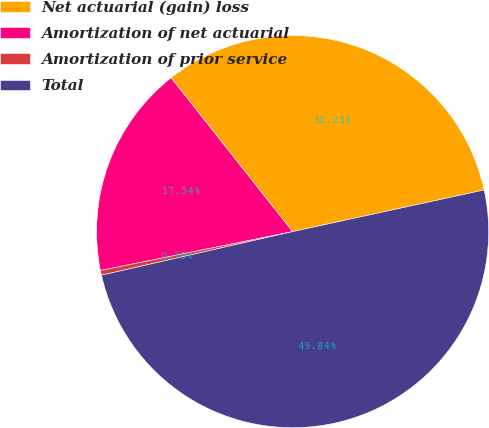Convert chart. <chart><loc_0><loc_0><loc_500><loc_500><pie_chart><fcel>Net actuarial (gain) loss<fcel>Amortization of net actuarial<fcel>Amortization of prior service<fcel>Total<nl><fcel>32.23%<fcel>17.54%<fcel>0.39%<fcel>49.84%<nl></chart> 